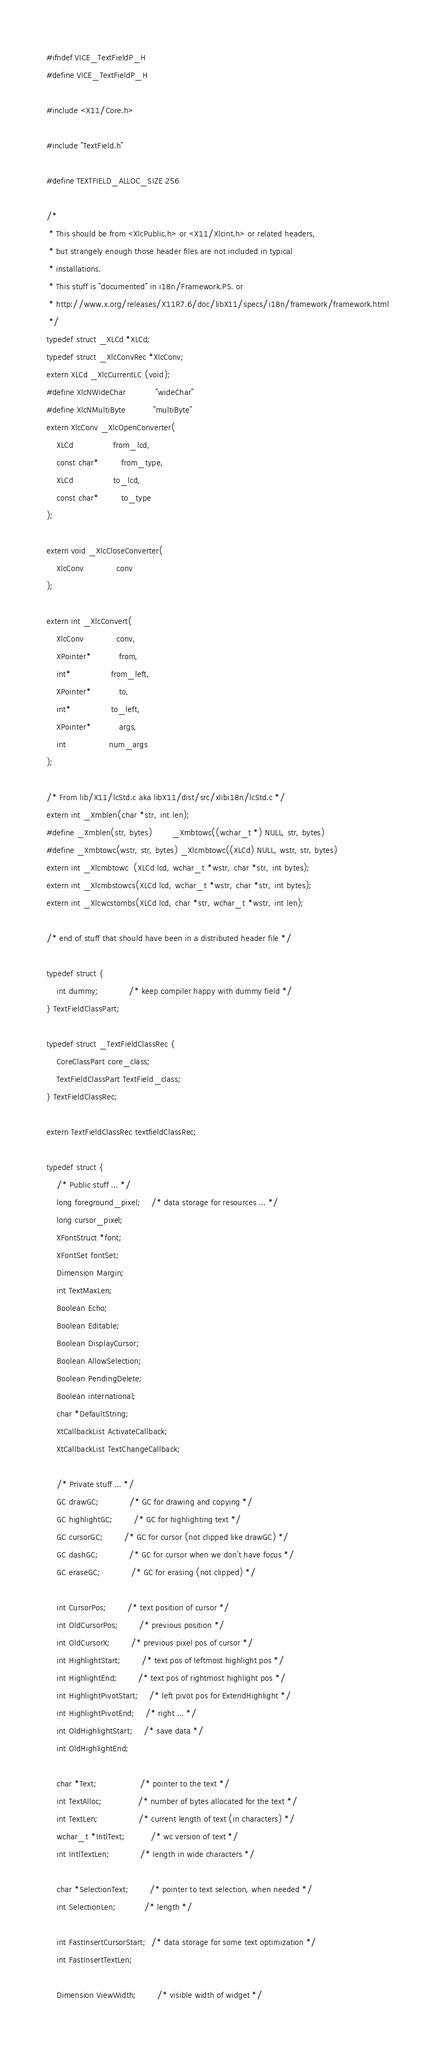<code> <loc_0><loc_0><loc_500><loc_500><_C_>
#ifndef VICE_TextFieldP_H
#define VICE_TextFieldP_H

#include <X11/Core.h>

#include "TextField.h"

#define TEXTFIELD_ALLOC_SIZE	256

/*
 * This should be from <XlcPublic.h> or <X11/Xlcint.h> or related headers,
 * but strangely enough those header files are not included in typical
 * installations.
 * This stuff is "documented" in i18n/Framework.PS. or
 * http://www.x.org/releases/X11R7.6/doc/libX11/specs/i18n/framework/framework.html
 */
typedef struct _XLCd *XLCd;
typedef struct _XlcConvRec *XlcConv;
extern XLCd _XlcCurrentLC (void);
#define XlcNWideChar            "wideChar"
#define XlcNMultiByte           "multiByte"
extern XlcConv _XlcOpenConverter(
    XLCd                from_lcd,
    const char*         from_type,
    XLCd                to_lcd,
    const char*         to_type
);

extern void _XlcCloseConverter(
    XlcConv             conv
);

extern int _XlcConvert(
    XlcConv             conv,
    XPointer*           from,
    int*                from_left,
    XPointer*           to,
    int*                to_left,
    XPointer*           args,
    int                 num_args
);

/* From lib/X11/lcStd.c aka libX11/dist/src/xlibi18n/lcStd.c */
extern int _Xmblen(char *str, int len);
#define _Xmblen(str, bytes)        _Xmbtowc((wchar_t *) NULL, str, bytes)
#define _Xmbtowc(wstr, str, bytes) _Xlcmbtowc((XLCd) NULL, wstr, str, bytes)
extern int _Xlcmbtowc  (XLCd lcd, wchar_t *wstr, char *str, int bytes);
extern int _Xlcmbstowcs(XLCd lcd, wchar_t *wstr, char *str, int bytes);
extern int _Xlcwcstombs(XLCd lcd, char *str, wchar_t *wstr, int len);

/* end of stuff that should have been in a distributed header file */

typedef struct {
    int dummy;			/* keep compiler happy with dummy field */
} TextFieldClassPart;

typedef struct _TextFieldClassRec {
    CoreClassPart core_class;
    TextFieldClassPart TextField_class;
} TextFieldClassRec;

extern TextFieldClassRec textfieldClassRec;

typedef struct {
    /* Public stuff ... */
    long foreground_pixel;	/* data storage for resources ... */
    long cursor_pixel;
    XFontStruct *font;
    XFontSet fontSet;
    Dimension Margin;
    int TextMaxLen;
    Boolean Echo;
    Boolean Editable;
    Boolean DisplayCursor;
    Boolean AllowSelection;
    Boolean PendingDelete;
    Boolean international;
    char *DefaultString;
    XtCallbackList ActivateCallback;
    XtCallbackList TextChangeCallback;

    /* Private stuff ... */
    GC drawGC;			/* GC for drawing and copying */
    GC highlightGC;		/* GC for highlighting text */
    GC cursorGC;		/* GC for cursor (not clipped like drawGC) */
    GC dashGC;			/* GC for cursor when we don't have focus */
    GC eraseGC;			/* GC for erasing (not clipped) */

    int CursorPos;		/* text position of cursor */
    int OldCursorPos;		/* previous position */
    int OldCursorX;		/* previous pixel pos of cursor */
    int HighlightStart;		/* text pos of leftmost highlight pos */
    int HighlightEnd;		/* text pos of rightmost highlight pos */
    int HighlightPivotStart;	/* left pivot pos for ExtendHighlight */
    int HighlightPivotEnd;	/* right ... */
    int OldHighlightStart;	/* save data */
    int OldHighlightEnd;

    char *Text;                 /* pointer to the text */
    int TextAlloc;              /* number of bytes allocated for the text */
    int TextLen;                /* current length of text (in characters) */
    wchar_t *IntlText;          /* wc version of text */
    int IntlTextLen;            /* length in wide characters */

    char *SelectionText;        /* pointer to text selection, when needed */
    int SelectionLen;           /* length */

    int FastInsertCursorStart;  /* data storage for some text optimization */
    int FastInsertTextLen;

    Dimension ViewWidth;        /* visible width of widget */</code> 